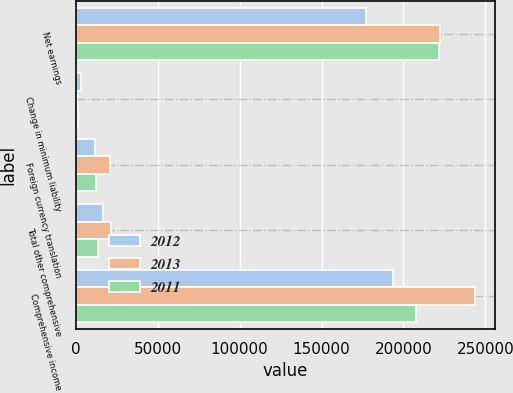Convert chart to OTSL. <chart><loc_0><loc_0><loc_500><loc_500><stacked_bar_chart><ecel><fcel>Net earnings<fcel>Change in minimum liability<fcel>Foreign currency translation<fcel>Total other comprehensive<fcel>Comprehensive income<nl><fcel>2012<fcel>177015<fcel>2961<fcel>11838<fcel>16459<fcel>193474<nl><fcel>2013<fcel>222398<fcel>745<fcel>20790<fcel>21535<fcel>243933<nl><fcel>2011<fcel>221474<fcel>1113<fcel>12533<fcel>13646<fcel>207828<nl></chart> 